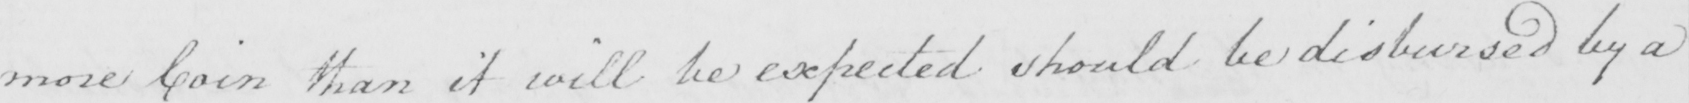What text is written in this handwritten line? more Coin that it will be expected should be disbursed by a 